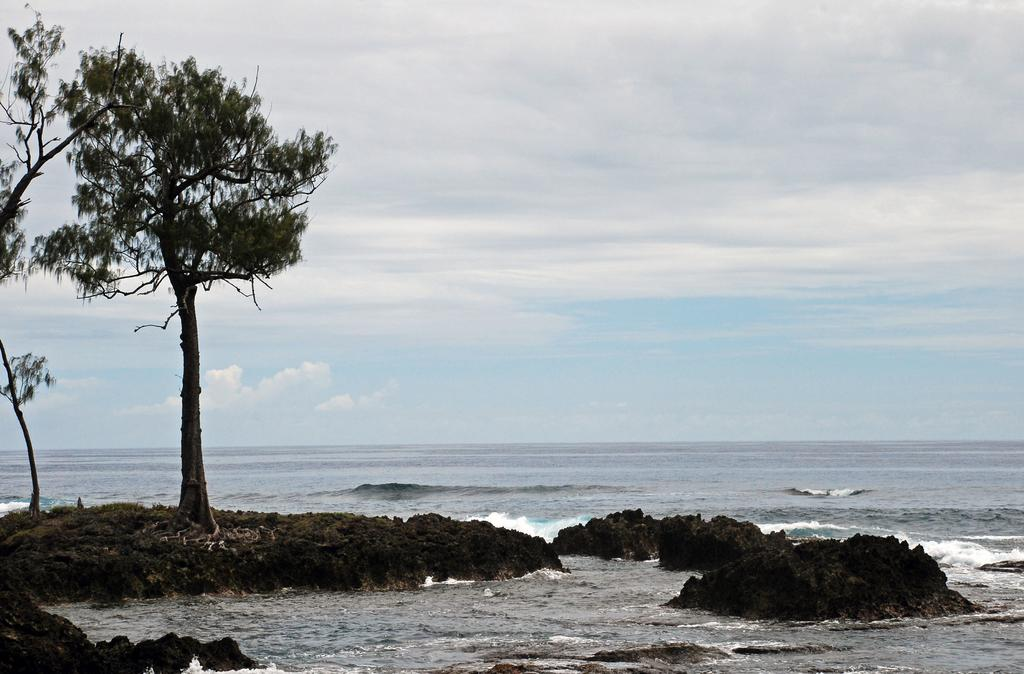What is the primary element in the image? There is water in the image. What other objects or features can be seen in the image? There are rocks and trees in the image. What can be seen in the background of the image? The sky is visible in the background of the image. What is the condition of the sky in the image? Clouds are present in the sky. Where is the flock of sheep in the image? There is no flock of sheep present in the image. What role does the grandfather play in the image? There is no mention of a grandfather or any person in the image. 